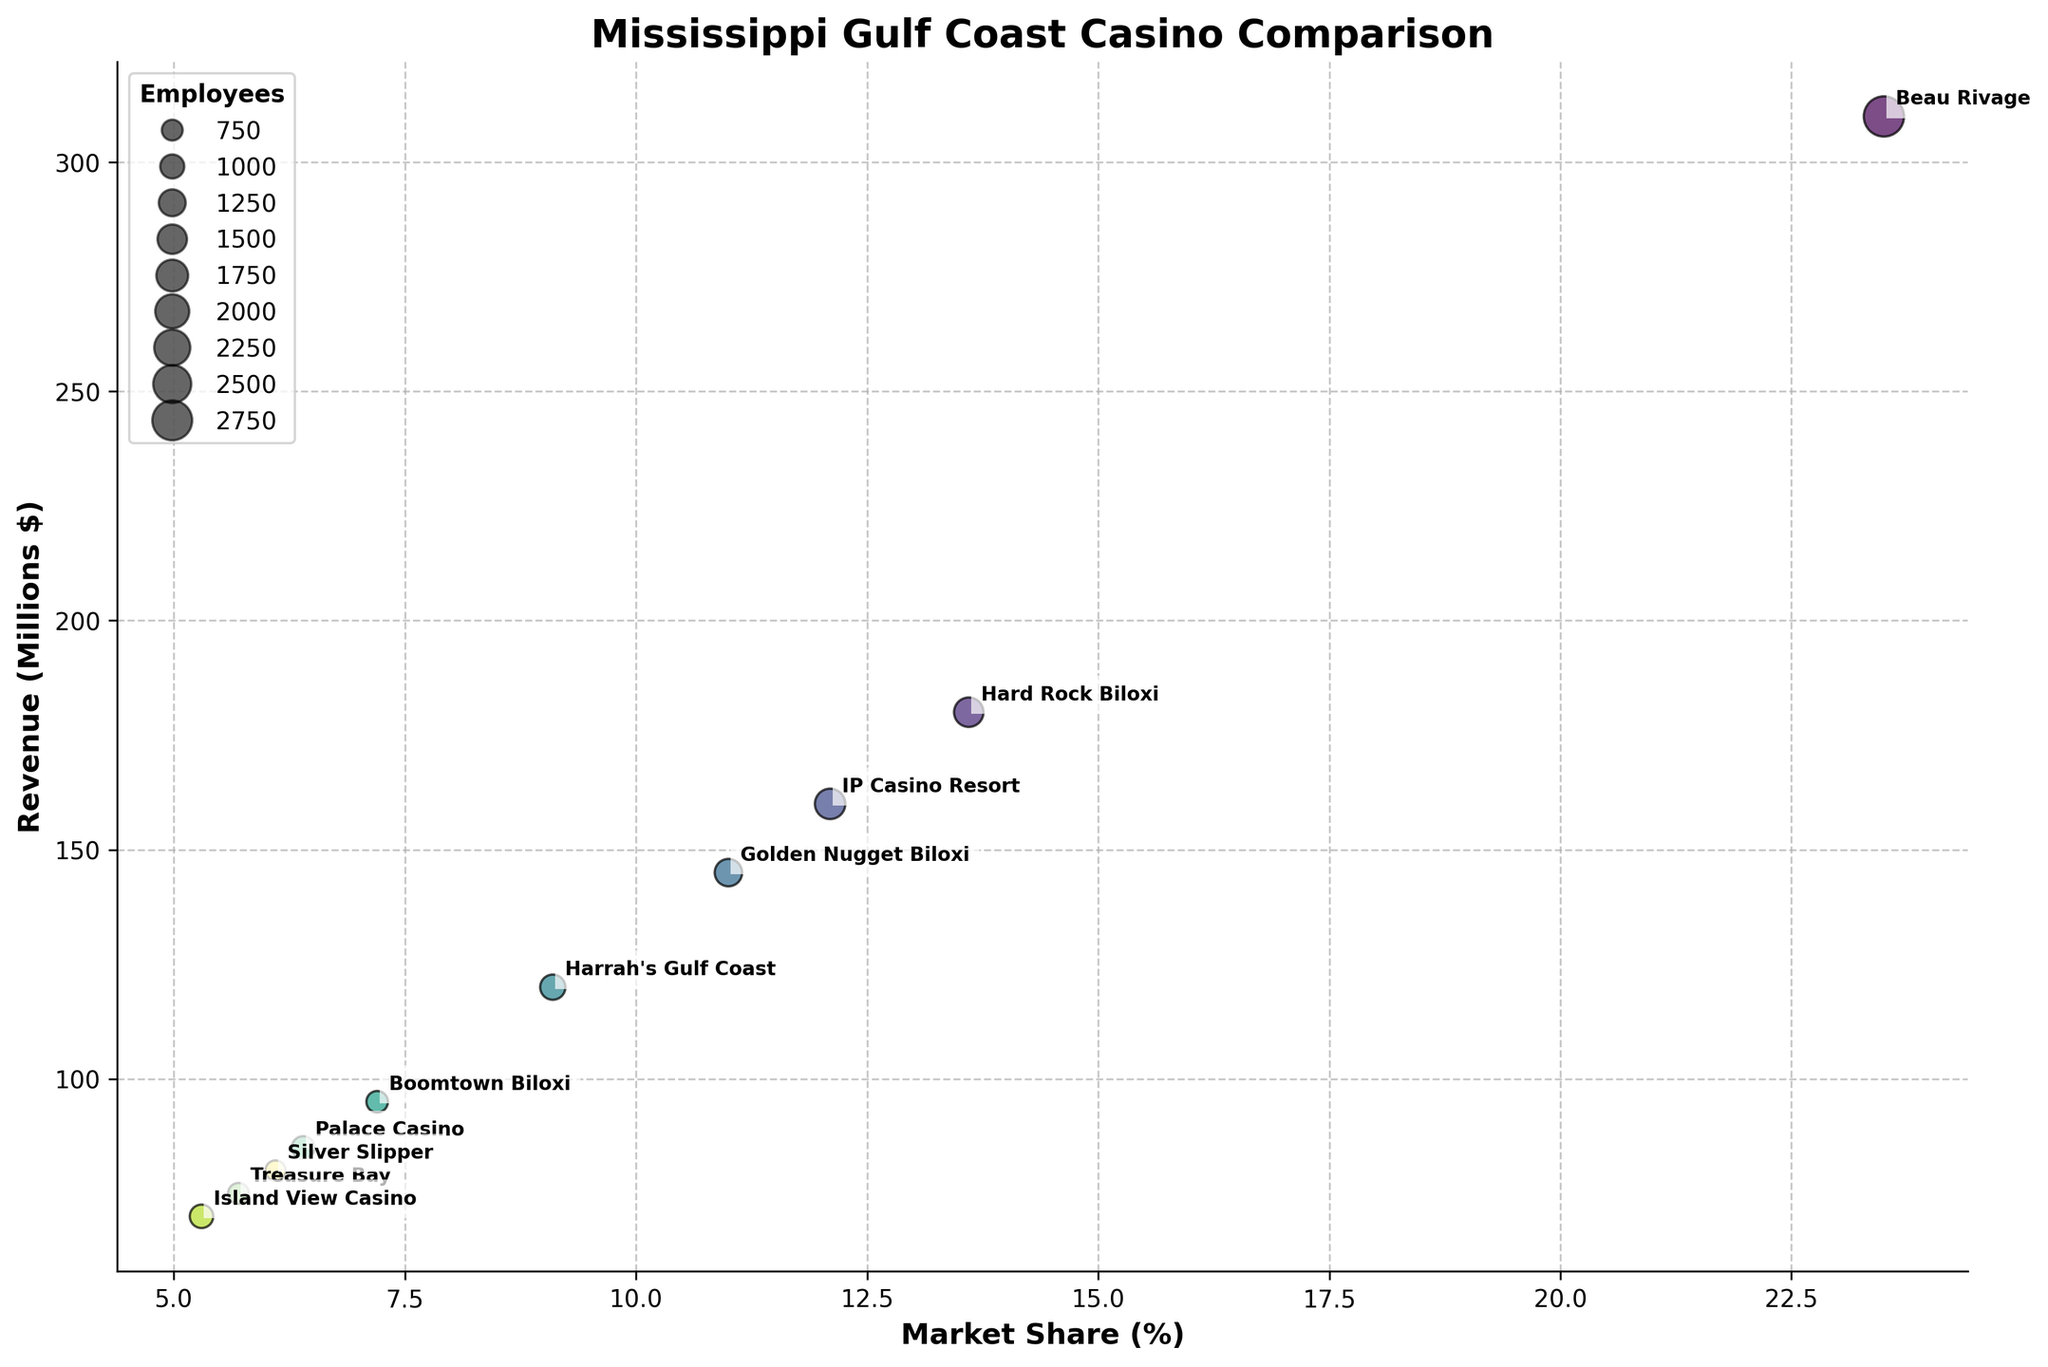What is the title of the figure? The title is usually placed at the top of the figure. In this figure, it is bold and easy to read.
Answer: Mississippi Gulf Coast Casino Comparison Which casino has the highest revenue? The casino with the highest revenue will be represented by the bubble at the highest point on the y-axis, and it is labeled with its name.
Answer: Beau Rivage How many employees does the Beau Rivage casino have? The number of employees can be identified by the size of the bubble corresponding to Beau Rivage, and this size-related information is mentioned in the legend.
Answer: 2800 What is the market share percentage of Hard Rock Biloxi? The market share is shown on the x-axis, and you can find Hard Rock Biloxi's market share by looking at the x-coordinate of its bubble.
Answer: 13.6% What is the difference in revenue between IP Casino Resort and Golden Nugget Biloxi? Find the revenue values on the y-axis for both IP Casino Resort and Golden Nugget Biloxi, then subtract the smaller revenue from the larger one.
Answer: 15 million dollars What is the combined market share of Beau Rivage and Hard Rock Biloxi? Add the market share percentages for Beau Rivage and Hard Rock Biloxi from their x-coordinates.
Answer: 37.1% Which casino has a bubble that represents roughly half the number of employees compared to Beau Rivage? Look at the bubble sizes in relation to Beau Rivage's bubble size. Identify the bubble that is approximately half that size and check its employee number in the legend.
Answer: Hard Rock Biloxi (1500 employees, roughly half of 2800) Is there a casino with both lower revenue and fewer employees than Harrah's Gulf Coast? Compare the bubbles' y-coordinates (revenue) and sizes (employees) to find any casino below and smaller than Harrah's Gulf Coast's bubble.
Answer: Yes (Boomtown Biloxi, Palace Casino, Treasure Bay, Island View Casino, Silver Slipper) How does the market share of Golden Nugget Biloxi compare to that of Silver Slipper? Compare the x-coordinates of the bubbles for Golden Nugget Biloxi and Silver Slipper to determine which is greater.
Answer: Golden Nugget Biloxi has a higher market share What is the average revenue of the bottom three casinos in terms of market share? Identify the bubbles with the three lowest x-coordinates (market share) and take the average of their y-coordinates (revenue).
Answer: (75 + 70 + 80) / 3 = 75 million dollars 